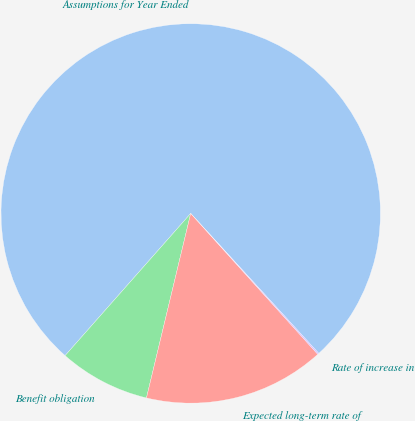Convert chart. <chart><loc_0><loc_0><loc_500><loc_500><pie_chart><fcel>Assumptions for Year Ended<fcel>Benefit obligation<fcel>Expected long-term rate of<fcel>Rate of increase in<nl><fcel>76.69%<fcel>7.77%<fcel>15.43%<fcel>0.11%<nl></chart> 